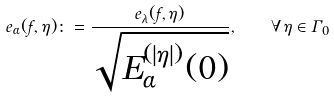Convert formula to latex. <formula><loc_0><loc_0><loc_500><loc_500>e _ { \alpha } ( f , \eta ) \colon = \frac { e _ { \lambda } ( f , \eta ) } { \sqrt { E _ { \alpha } ^ { ( | \eta | ) } ( 0 ) } } , \quad \forall \, \eta \in \Gamma _ { 0 }</formula> 